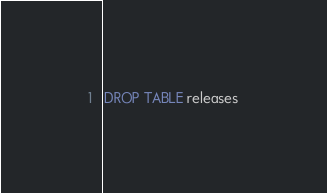Convert code to text. <code><loc_0><loc_0><loc_500><loc_500><_SQL_>DROP TABLE releases
</code> 